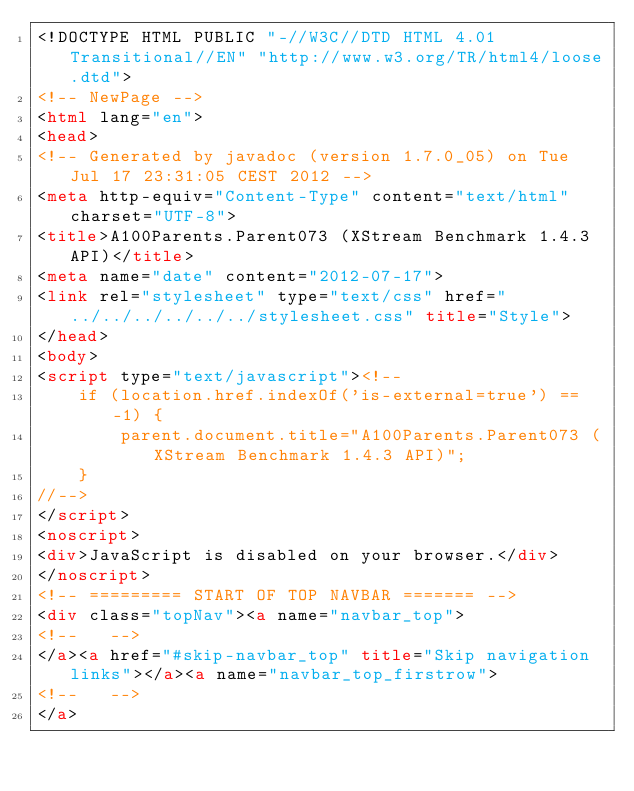Convert code to text. <code><loc_0><loc_0><loc_500><loc_500><_HTML_><!DOCTYPE HTML PUBLIC "-//W3C//DTD HTML 4.01 Transitional//EN" "http://www.w3.org/TR/html4/loose.dtd">
<!-- NewPage -->
<html lang="en">
<head>
<!-- Generated by javadoc (version 1.7.0_05) on Tue Jul 17 23:31:05 CEST 2012 -->
<meta http-equiv="Content-Type" content="text/html" charset="UTF-8">
<title>A100Parents.Parent073 (XStream Benchmark 1.4.3 API)</title>
<meta name="date" content="2012-07-17">
<link rel="stylesheet" type="text/css" href="../../../../../../stylesheet.css" title="Style">
</head>
<body>
<script type="text/javascript"><!--
    if (location.href.indexOf('is-external=true') == -1) {
        parent.document.title="A100Parents.Parent073 (XStream Benchmark 1.4.3 API)";
    }
//-->
</script>
<noscript>
<div>JavaScript is disabled on your browser.</div>
</noscript>
<!-- ========= START OF TOP NAVBAR ======= -->
<div class="topNav"><a name="navbar_top">
<!--   -->
</a><a href="#skip-navbar_top" title="Skip navigation links"></a><a name="navbar_top_firstrow">
<!--   -->
</a></code> 